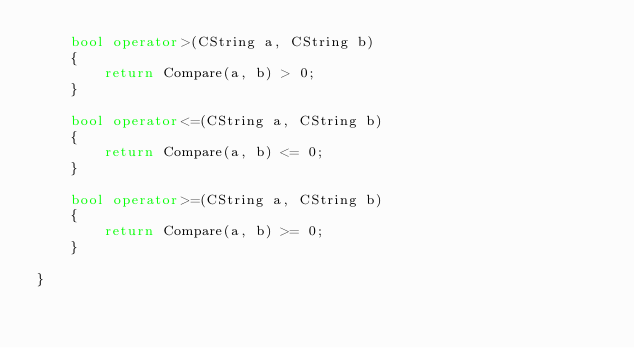<code> <loc_0><loc_0><loc_500><loc_500><_C++_>    bool operator>(CString a, CString b)
    {
        return Compare(a, b) > 0;
    }

    bool operator<=(CString a, CString b)
    {
        return Compare(a, b) <= 0;
    }

    bool operator>=(CString a, CString b)
    {
        return Compare(a, b) >= 0;
    }

}
</code> 